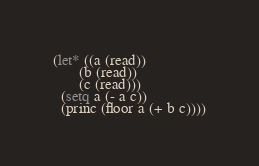<code> <loc_0><loc_0><loc_500><loc_500><_Lisp_>(let* ((a (read))
       (b (read))
       (c (read)))
  (setq a (- a c))
  (princ (floor a (+ b c))))</code> 